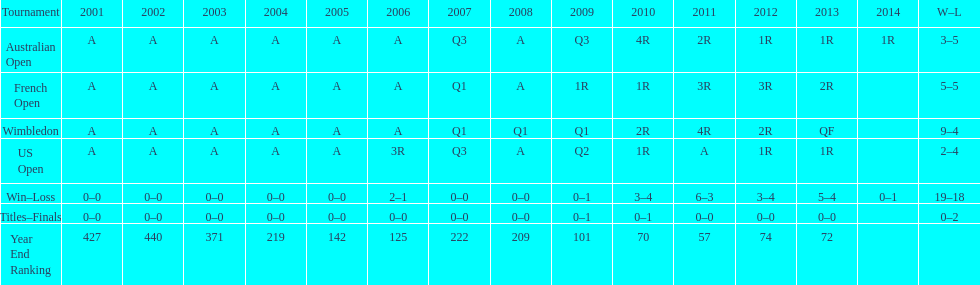How many tournaments had 5 total losses? 2. 